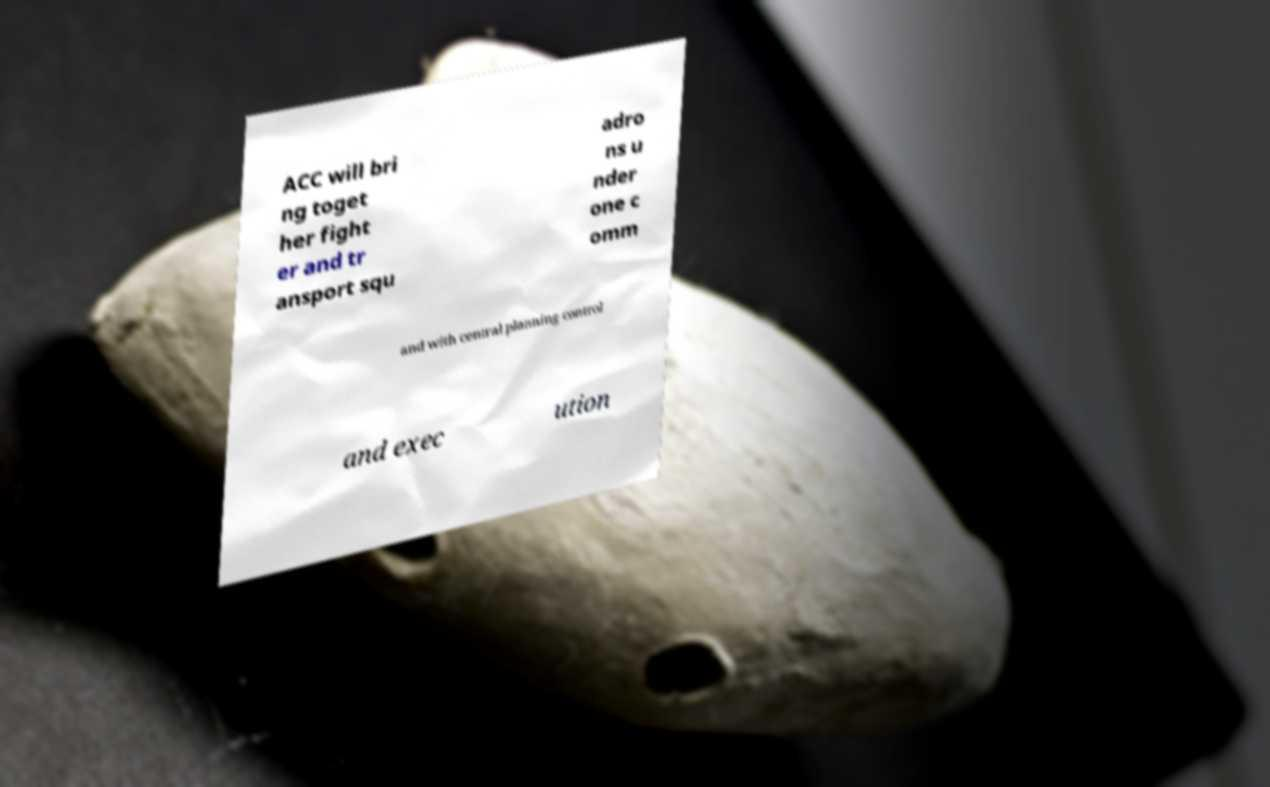Please identify and transcribe the text found in this image. ACC will bri ng toget her fight er and tr ansport squ adro ns u nder one c omm and with central planning control and exec ution 